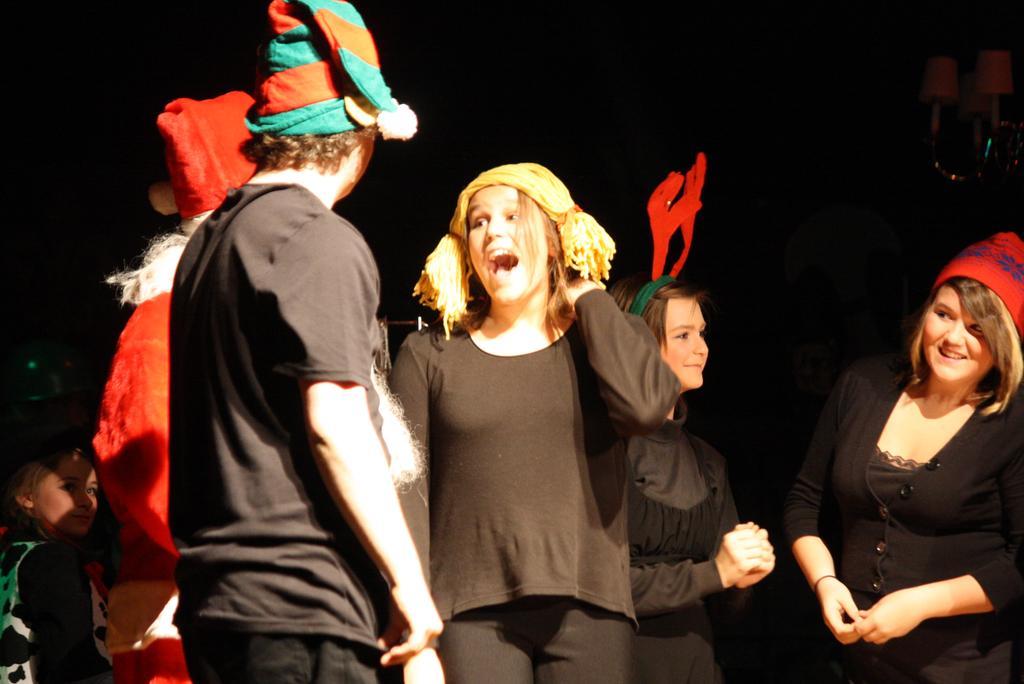Please provide a concise description of this image. Left side there is a person wearing a black shirt is wearing a cap. Behind there is a person wearing a red top is having a cap. Left bottom there is a woman. Right side there are three women wearing a black top. Right side woman is wearing a red color cap. Background is in black color. 